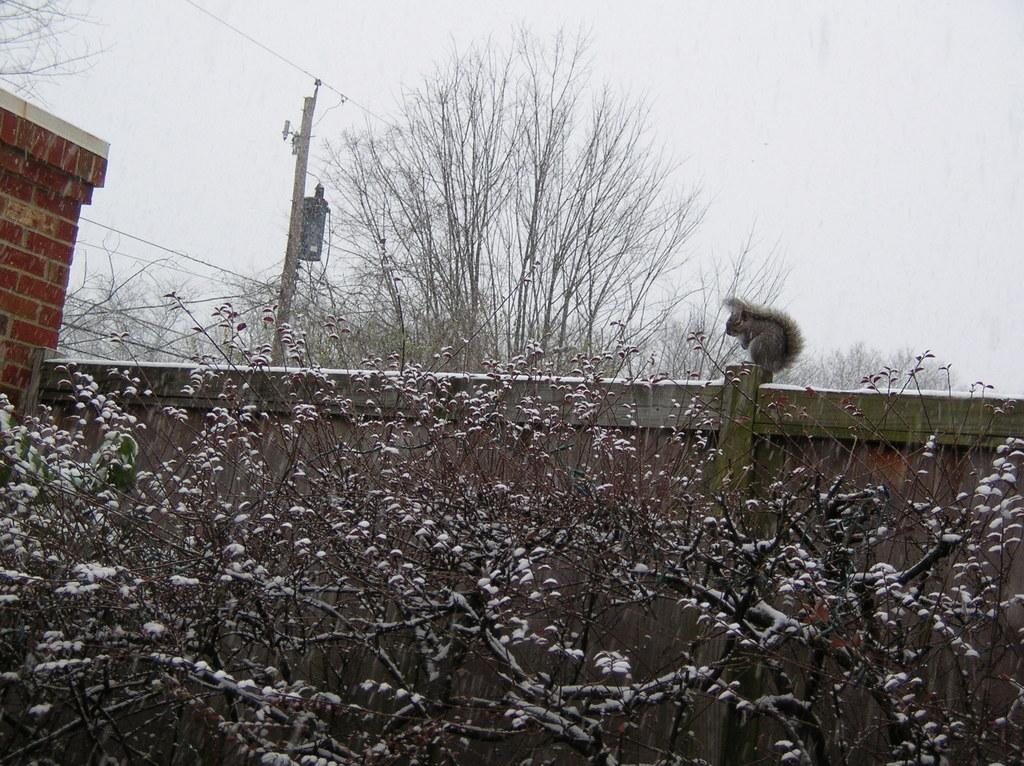What animal can be seen on the wall in the image? There is a squirrel on the wall in the image. What type of celestial bodies are depicted in the image? There are planets with snow in the image. What type of vegetation is visible in the background of the image? The background of the image includes trees. What architectural feature can be seen in the background of the image? There is a pole in the background of the image. What type of man-made structure is visible in the background of the image? There is a brick wall in the background of the image. What other objects can be seen in the background of the image? There is an unspecified object in the background of the image. What part of the natural environment is visible in the background of the image? The sky is visible in the background of the image. What type of vase is visible in the image? There is no vase present in the image. What type of field can be seen in the image? There is no field present in the image. 